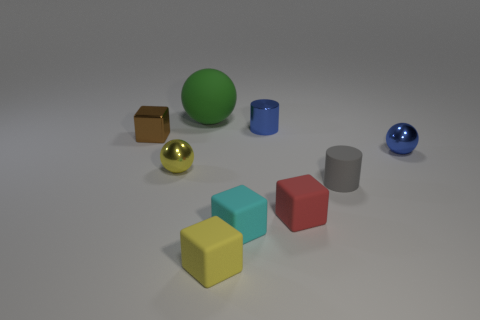Subtract all yellow blocks. How many blocks are left? 3 Subtract all cubes. How many objects are left? 5 Subtract all blue balls. How many balls are left? 2 Subtract 2 cubes. How many cubes are left? 2 Subtract all gray cylinders. Subtract all red balls. How many cylinders are left? 1 Subtract all gray spheres. How many gray cylinders are left? 1 Subtract all large brown shiny balls. Subtract all tiny yellow rubber cubes. How many objects are left? 8 Add 7 small red rubber things. How many small red rubber things are left? 8 Add 9 yellow balls. How many yellow balls exist? 10 Subtract 1 yellow spheres. How many objects are left? 8 